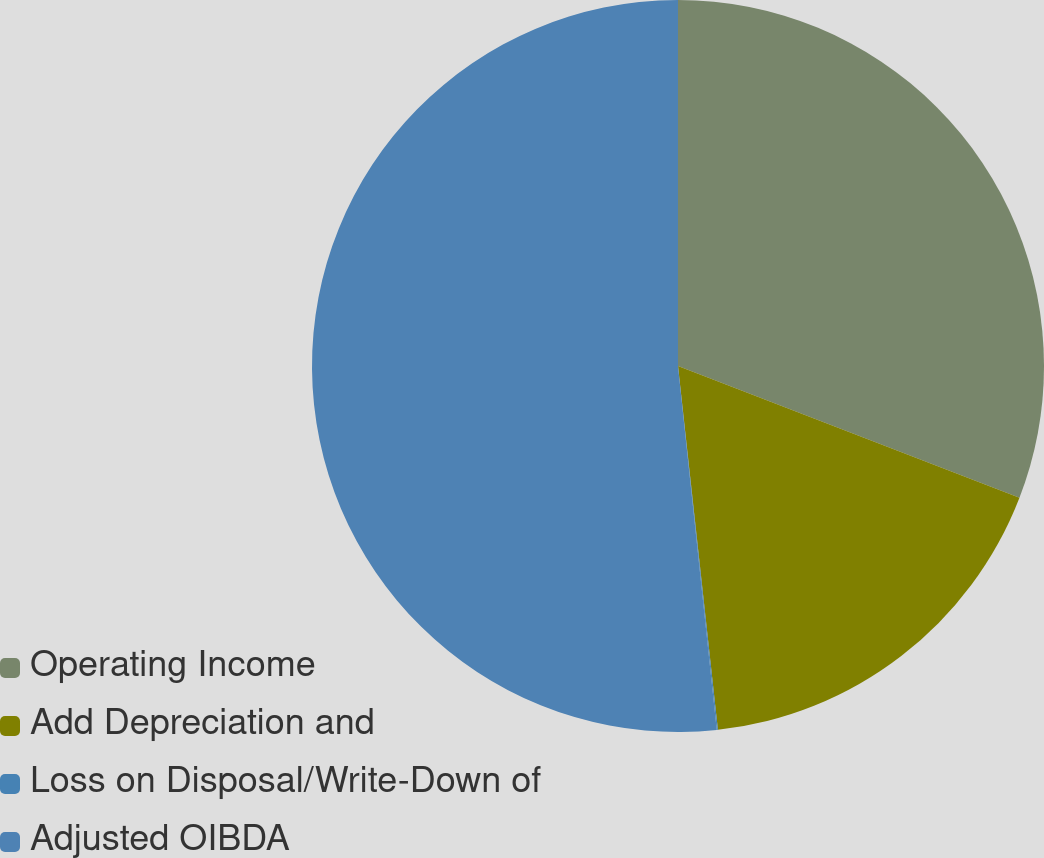<chart> <loc_0><loc_0><loc_500><loc_500><pie_chart><fcel>Operating Income<fcel>Add Depreciation and<fcel>Loss on Disposal/Write-Down of<fcel>Adjusted OIBDA<nl><fcel>30.86%<fcel>17.4%<fcel>0.05%<fcel>51.69%<nl></chart> 